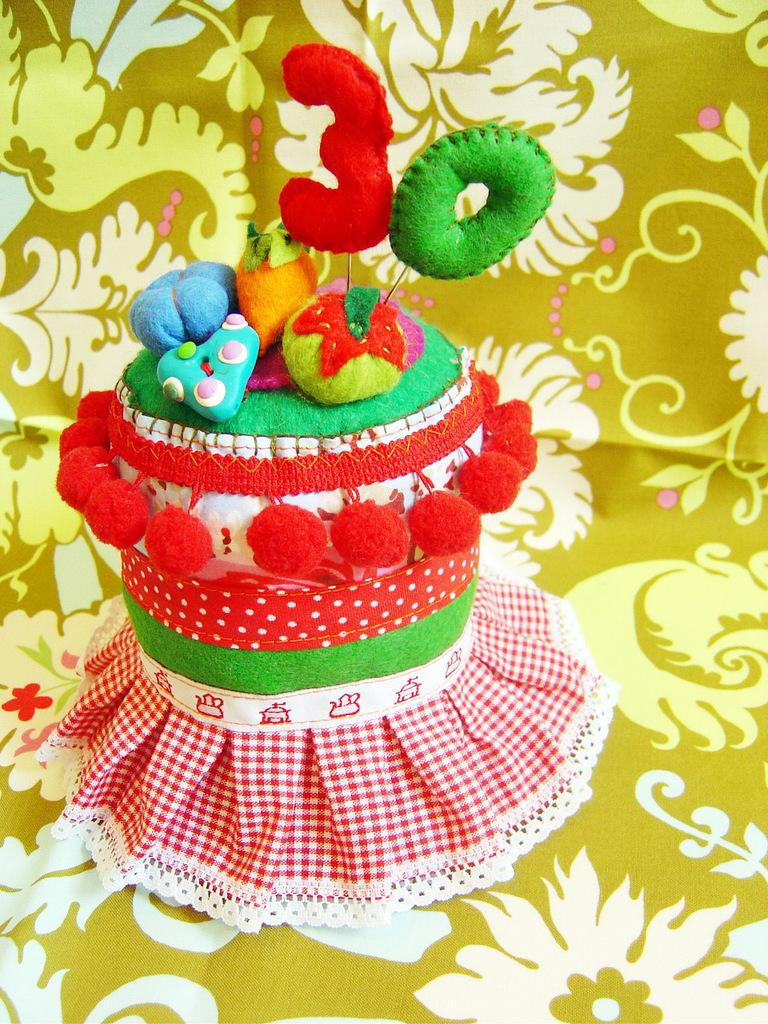What is the main subject of the image? There is a craft in the image. How does the craft resemble another object? The craft resembles a cake. What is placed on the craft? There are candles and eatable things on the craft. What is the cloth in the image used for? The cloth has a design printed on it. How is the craft positioned in the image? The craft is placed on the design printed cloth. What time of day is the fireman shown rescuing someone on the coast in the image? There is no fireman or coast present in the image; it features a craft with candles and eatable things on a cloth with a design. 